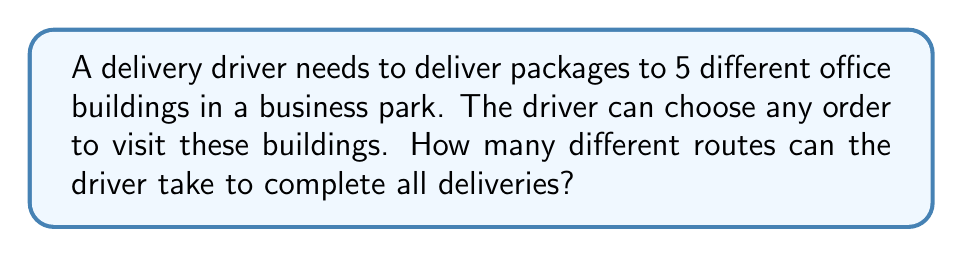Help me with this question. Let's approach this step-by-step:

1) This problem is a permutation question. We need to determine how many ways we can arrange 5 distinct items (the office buildings).

2) In permutation problems, the order matters. The driver visiting buildings A, B, C, D, E is considered a different route than visiting B, A, C, D, E.

3) For the first stop, the driver has 5 choices of buildings.

4) For the second stop, there are only 4 remaining buildings to choose from.

5) For the third stop, there are 3 choices left.

6) For the fourth stop, there are 2 choices left.

7) For the last stop, there is only 1 building left to visit.

8) According to the multiplication principle, we multiply these numbers together:

   $$ 5 \times 4 \times 3 \times 2 \times 1 = 120 $$

9) This is also known as 5 factorial, written as 5!:

   $$ 5! = 5 \times 4 \times 3 \times 2 \times 1 = 120 $$

Therefore, the driver can take 120 different routes to complete all deliveries.
Answer: 120 